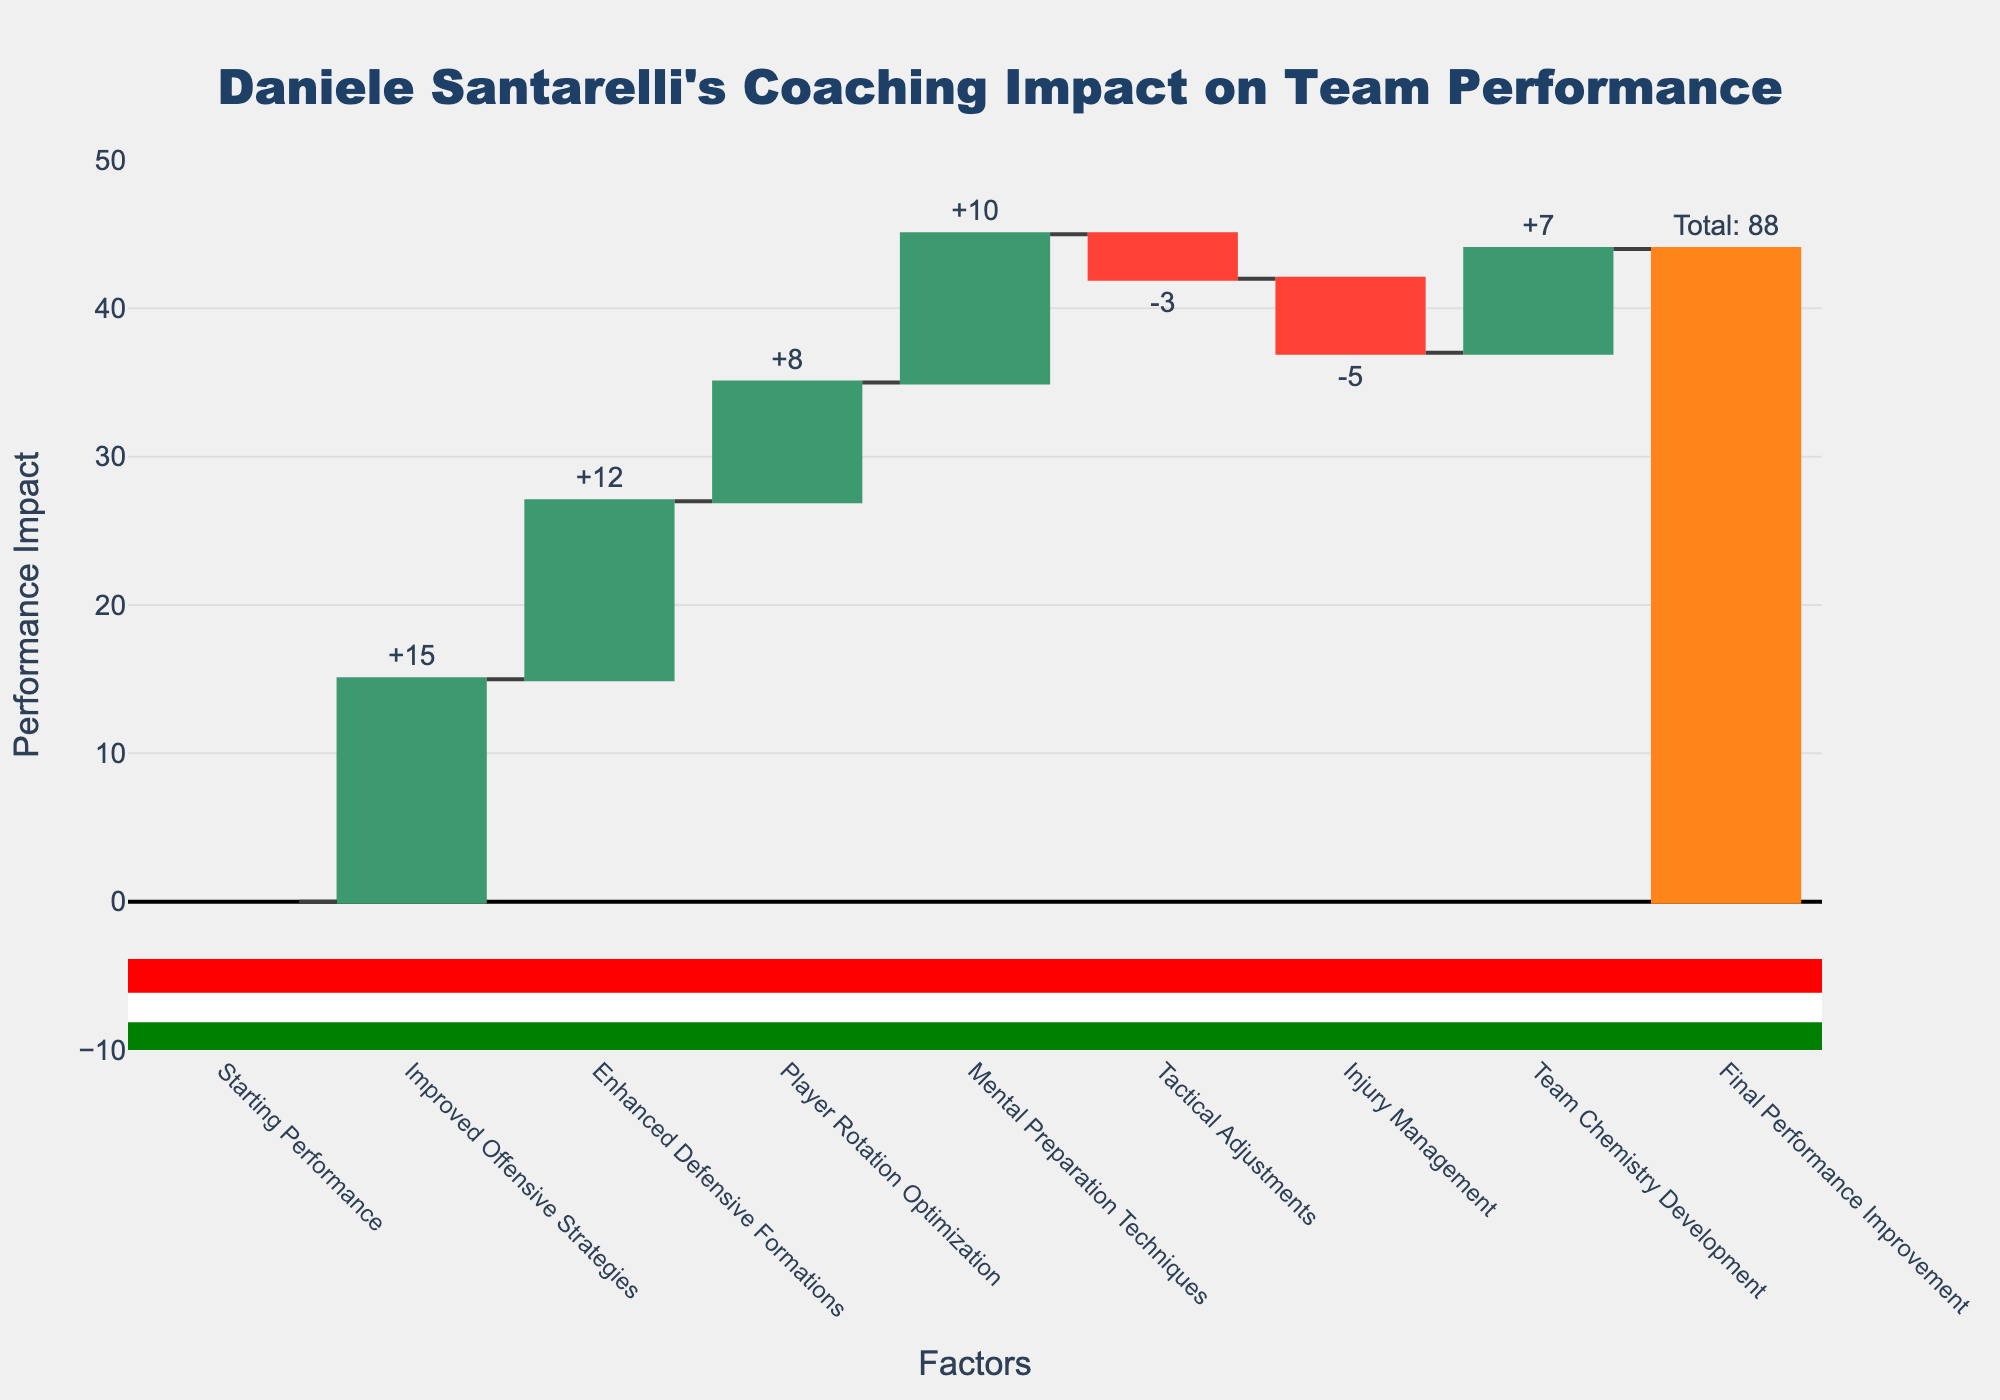How much did the improved offensive strategies impact the team's performance? The waterfall chart shows a bar labeled "Improved Offensive Strategies" with a value of +15. This means that the improved offensive strategies contributed a 15-point increase to the team's performance.
Answer: +15 What is the total performance improvement at the end of the season? The final bar labeled "Final Performance Improvement" shows the accumulated total of all the contributions from the different factors. The total performance improvement is indicated as 44.
Answer: 44 Which factor had the largest negative impact on the team's performance? The waterfall chart has only two negative impacts, "Tactical Adjustments" and "Injury Management." Among these, "Injury Management" has a value of -5, while "Tactical Adjustments" is -3. Hence, "Injury Management" had the largest negative impact.
Answer: Injury Management What is the combined impact of the player rotation optimization and mental preparation techniques? The values for "Player Rotation Optimization" and "Mental Preparation Techniques" are +8 and +10 respectively. Adding these together results in a combined impact of 8 + 10 = 18.
Answer: +18 How do the improvements in defensive formations and offensive strategies compare? The waterfall chart shows "Improved Offensive Strategies" with a value of +15 and "Enhanced Defensive Formations" with a value of +12. Comparing these, offensive strategies improved the performance more by 3 points (15 - 12).
Answer: Offensive strategies by +3 What was the effect of tactical adjustments on the team's performance? The bar labeled "Tactical Adjustments" shows a value of -3, indicating that the tactical adjustments negatively impacted the team's performance by 3 points.
Answer: -3 What factor contributed the least to the performance improvement? By observing the positive values, "Player Rotation Optimization," which has a value of +8, contributed the least to the performance improvement when compared to other positive factors.
Answer: Player Rotation Optimization What is the net impact of negative factors on the team's performance? The negative impacts in the waterfall chart are "Tactical Adjustments" with -3 and "Injury Management" with -5. Adding these together results in a net negative impact of -3 + -5 = -8.
Answer: -8 Did the enhancements in defensive formations provide a greater impact than mental preparation techniques? The chart shows "Enhanced Defensive Formations" with a value of +12 and "Mental Preparation Techniques" with a value of +10. The enhancements in defensive formations had a greater impact than mental preparation techniques by 2 points (12 - 10).
Answer: No, defensive formations had a greater impact by +2 What visual elements are used to represent increasing and decreasing factors in performance? In the waterfall chart, increasing factors are represented by green bars, while decreasing factors are shown with red bars. The total performance improvement is displayed with an orange bar.
Answer: Green bars for increases, red bars for decreases, orange bar for total 